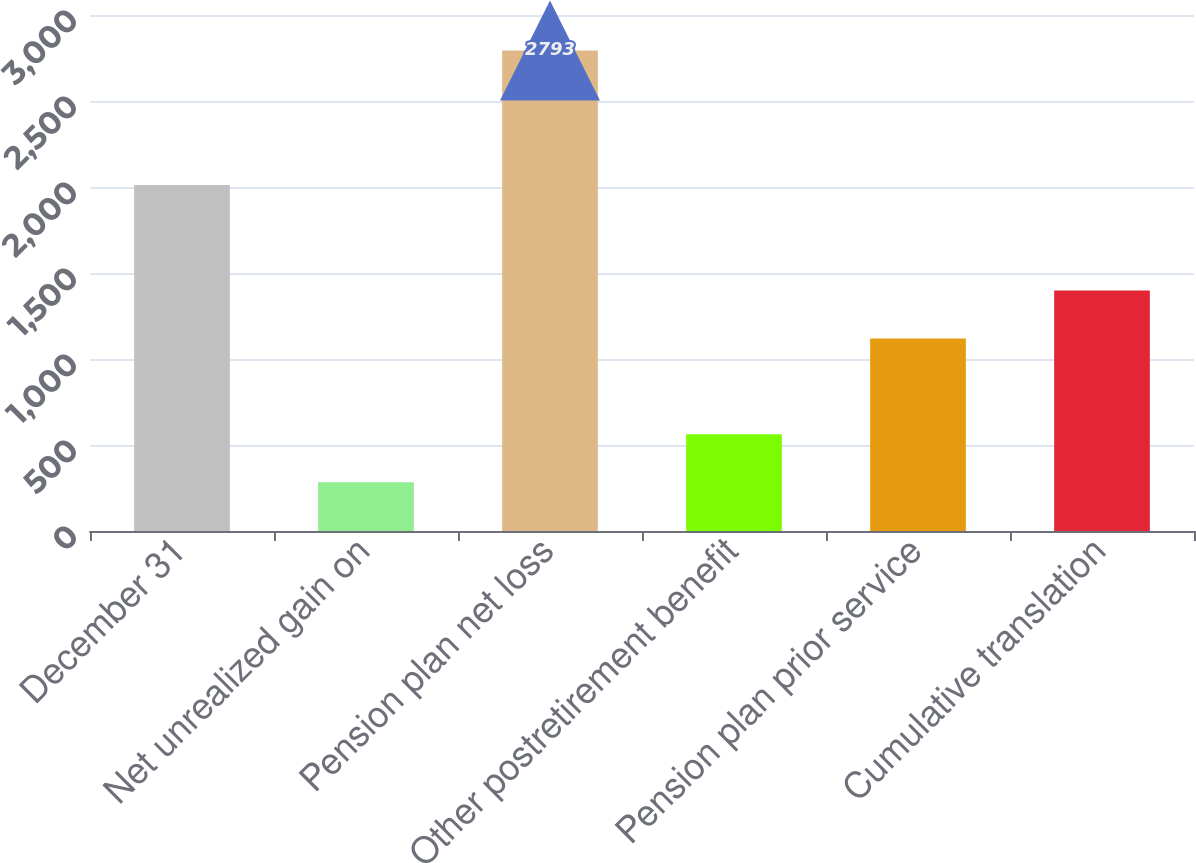Convert chart. <chart><loc_0><loc_0><loc_500><loc_500><bar_chart><fcel>December 31<fcel>Net unrealized gain on<fcel>Pension plan net loss<fcel>Other postretirement benefit<fcel>Pension plan prior service<fcel>Cumulative translation<nl><fcel>2011<fcel>282.9<fcel>2793<fcel>561.8<fcel>1119.6<fcel>1398.5<nl></chart> 